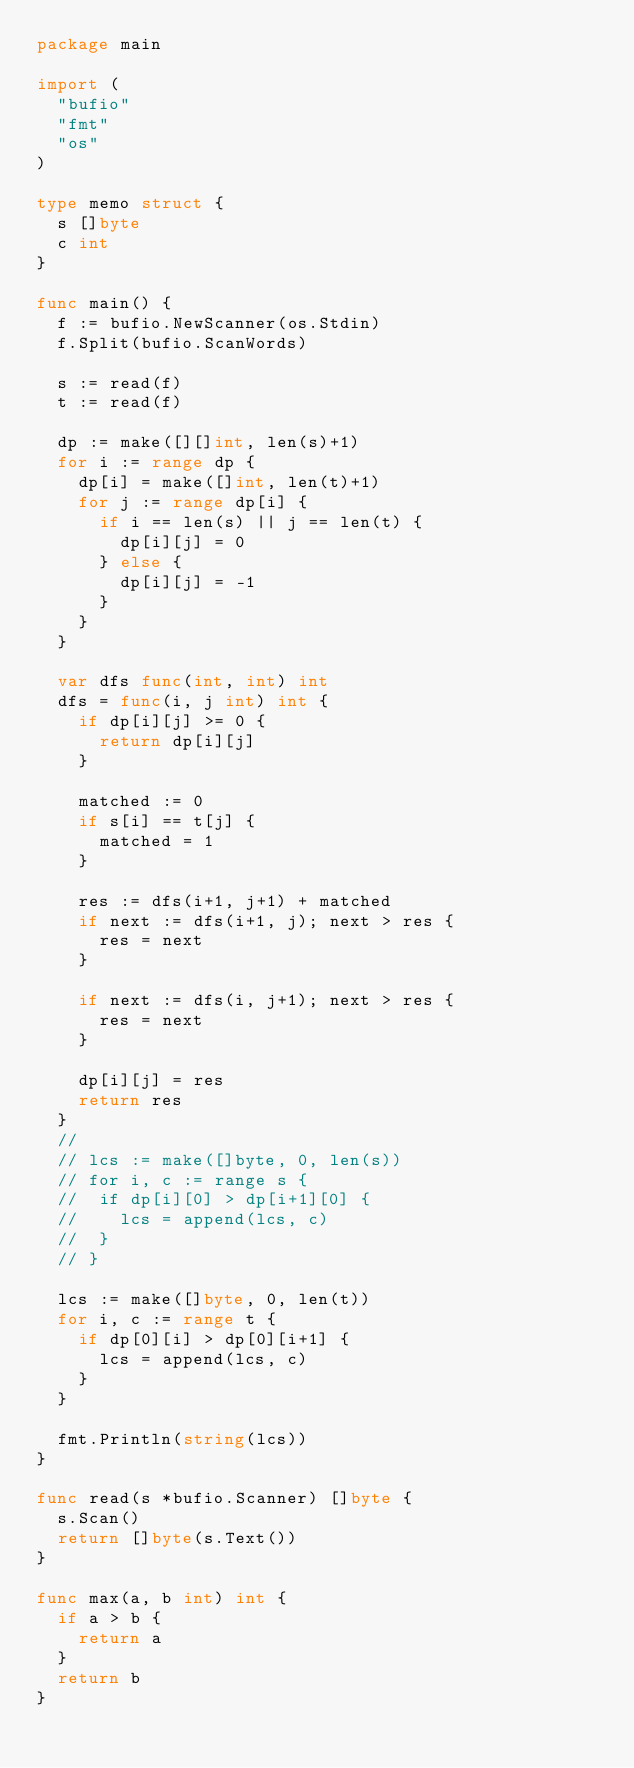<code> <loc_0><loc_0><loc_500><loc_500><_Go_>package main

import (
	"bufio"
	"fmt"
	"os"
)

type memo struct {
	s []byte
	c int
}

func main() {
	f := bufio.NewScanner(os.Stdin)
	f.Split(bufio.ScanWords)

	s := read(f)
	t := read(f)

	dp := make([][]int, len(s)+1)
	for i := range dp {
		dp[i] = make([]int, len(t)+1)
		for j := range dp[i] {
			if i == len(s) || j == len(t) {
				dp[i][j] = 0
			} else {
				dp[i][j] = -1
			}
		}
	}

	var dfs func(int, int) int
	dfs = func(i, j int) int {
		if dp[i][j] >= 0 {
			return dp[i][j]
		}

		matched := 0
		if s[i] == t[j] {
			matched = 1
		}

		res := dfs(i+1, j+1) + matched
		if next := dfs(i+1, j); next > res {
			res = next
		}

		if next := dfs(i, j+1); next > res {
			res = next
		}

		dp[i][j] = res
		return res
	}
	//
	// lcs := make([]byte, 0, len(s))
	// for i, c := range s {
	// 	if dp[i][0] > dp[i+1][0] {
	// 		lcs = append(lcs, c)
	// 	}
	// }

	lcs := make([]byte, 0, len(t))
	for i, c := range t {
		if dp[0][i] > dp[0][i+1] {
			lcs = append(lcs, c)
		}
	}

	fmt.Println(string(lcs))
}

func read(s *bufio.Scanner) []byte {
	s.Scan()
	return []byte(s.Text())
}

func max(a, b int) int {
	if a > b {
		return a
	}
	return b
}
</code> 